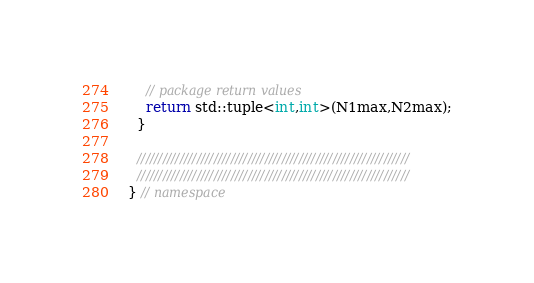Convert code to text. <code><loc_0><loc_0><loc_500><loc_500><_C++_>    // package return values
    return std::tuple<int,int>(N1max,N2max);
  }

  ////////////////////////////////////////////////////////////////
  ////////////////////////////////////////////////////////////////
} // namespace
</code> 